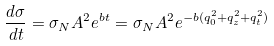Convert formula to latex. <formula><loc_0><loc_0><loc_500><loc_500>\frac { d \sigma } { d t } = \sigma _ { N } A ^ { 2 } e ^ { b t } = \sigma _ { N } A ^ { 2 } e ^ { - b ( q _ { 0 } ^ { 2 } + q _ { z } ^ { 2 } + q _ { t } ^ { 2 } ) }</formula> 